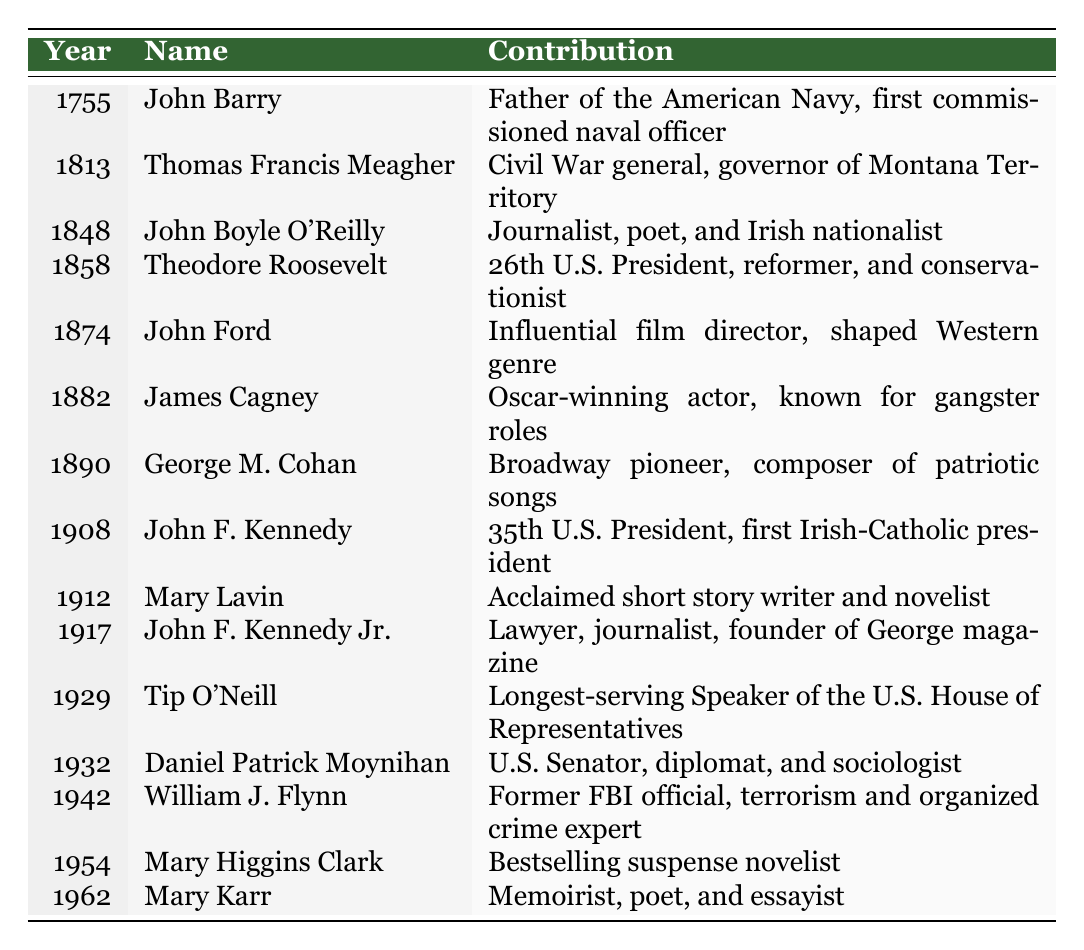What year was John Barry active? John Barry is listed in the table with the year 1755, which indicates the year he was active.
Answer: 1755 Who was the longest-serving Speaker of the U.S. House of Representatives? The table lists Tip O'Neill in 1929 as the longest-serving Speaker of the U.S. House of Representatives.
Answer: Tip O'Neill How many individuals listed in the table made significant contributions before the 20th century? The table contains entries for John Barry (1755), Thomas Francis Meagher (1813), John Boyle O'Reilly (1848), Theodore Roosevelt (1858), John Ford (1874), James Cagney (1882), and George M. Cohan (1890), which totals seven individuals before the 20th century.
Answer: 7 Did John F. Kennedy Jr. contribute to journalism? The table indicates that John F. Kennedy Jr. was a lawyer and journalist, hence the answer is true; he did contribute to journalism.
Answer: Yes Who was the first Irish-Catholic president of the U.S.? The table shows that John F. Kennedy, who served as the 35th U.S. President and is identified as the first Irish-Catholic president, is listed for the year 1908.
Answer: John F. Kennedy What major contributions did individuals from the 1930s to the 1960s make? From the table, Daniel Patrick Moynihan (1932) was a U.S. Senator and diplomat, William J. Flynn (1942) was an expert on terrorism and organized crime, Mary Higgins Clark (1954) was a bestselling novelist, and Mary Karr (1962) was a memoirist. Summarizing, they contributed in politics, law enforcement, literature, and memoir writing.
Answer: Politics, law enforcement, literature, memoir writing Which film director and what specific genre did they influence? The table notes that John Ford, listed for 1874, was an influential film director who shaped the Western genre.
Answer: Western genre What was the contribution of George M. Cohan? According to the table, George M. Cohan contributed as a Broadway pioneer and composer of patriotic songs in the year 1890.
Answer: Broadway pioneer, composer Which two individuals listed were involved in the military? The table indicates that Thomas Francis Meagher (1813), a Civil War general, and John Barry (1755), the Father of the American Navy, were both military figures.
Answer: Thomas Francis Meagher, John Barry What trends can you observe regarding the contributions of Irish-Americans in various fields over time? The table shows a progression from military and political contributions in the 18th and 19th centuries to cultural contributions in literature, film, and suspense novels in the 20th century, indicating a widening scope of influence.
Answer: Broader influence in culture and politics over time 